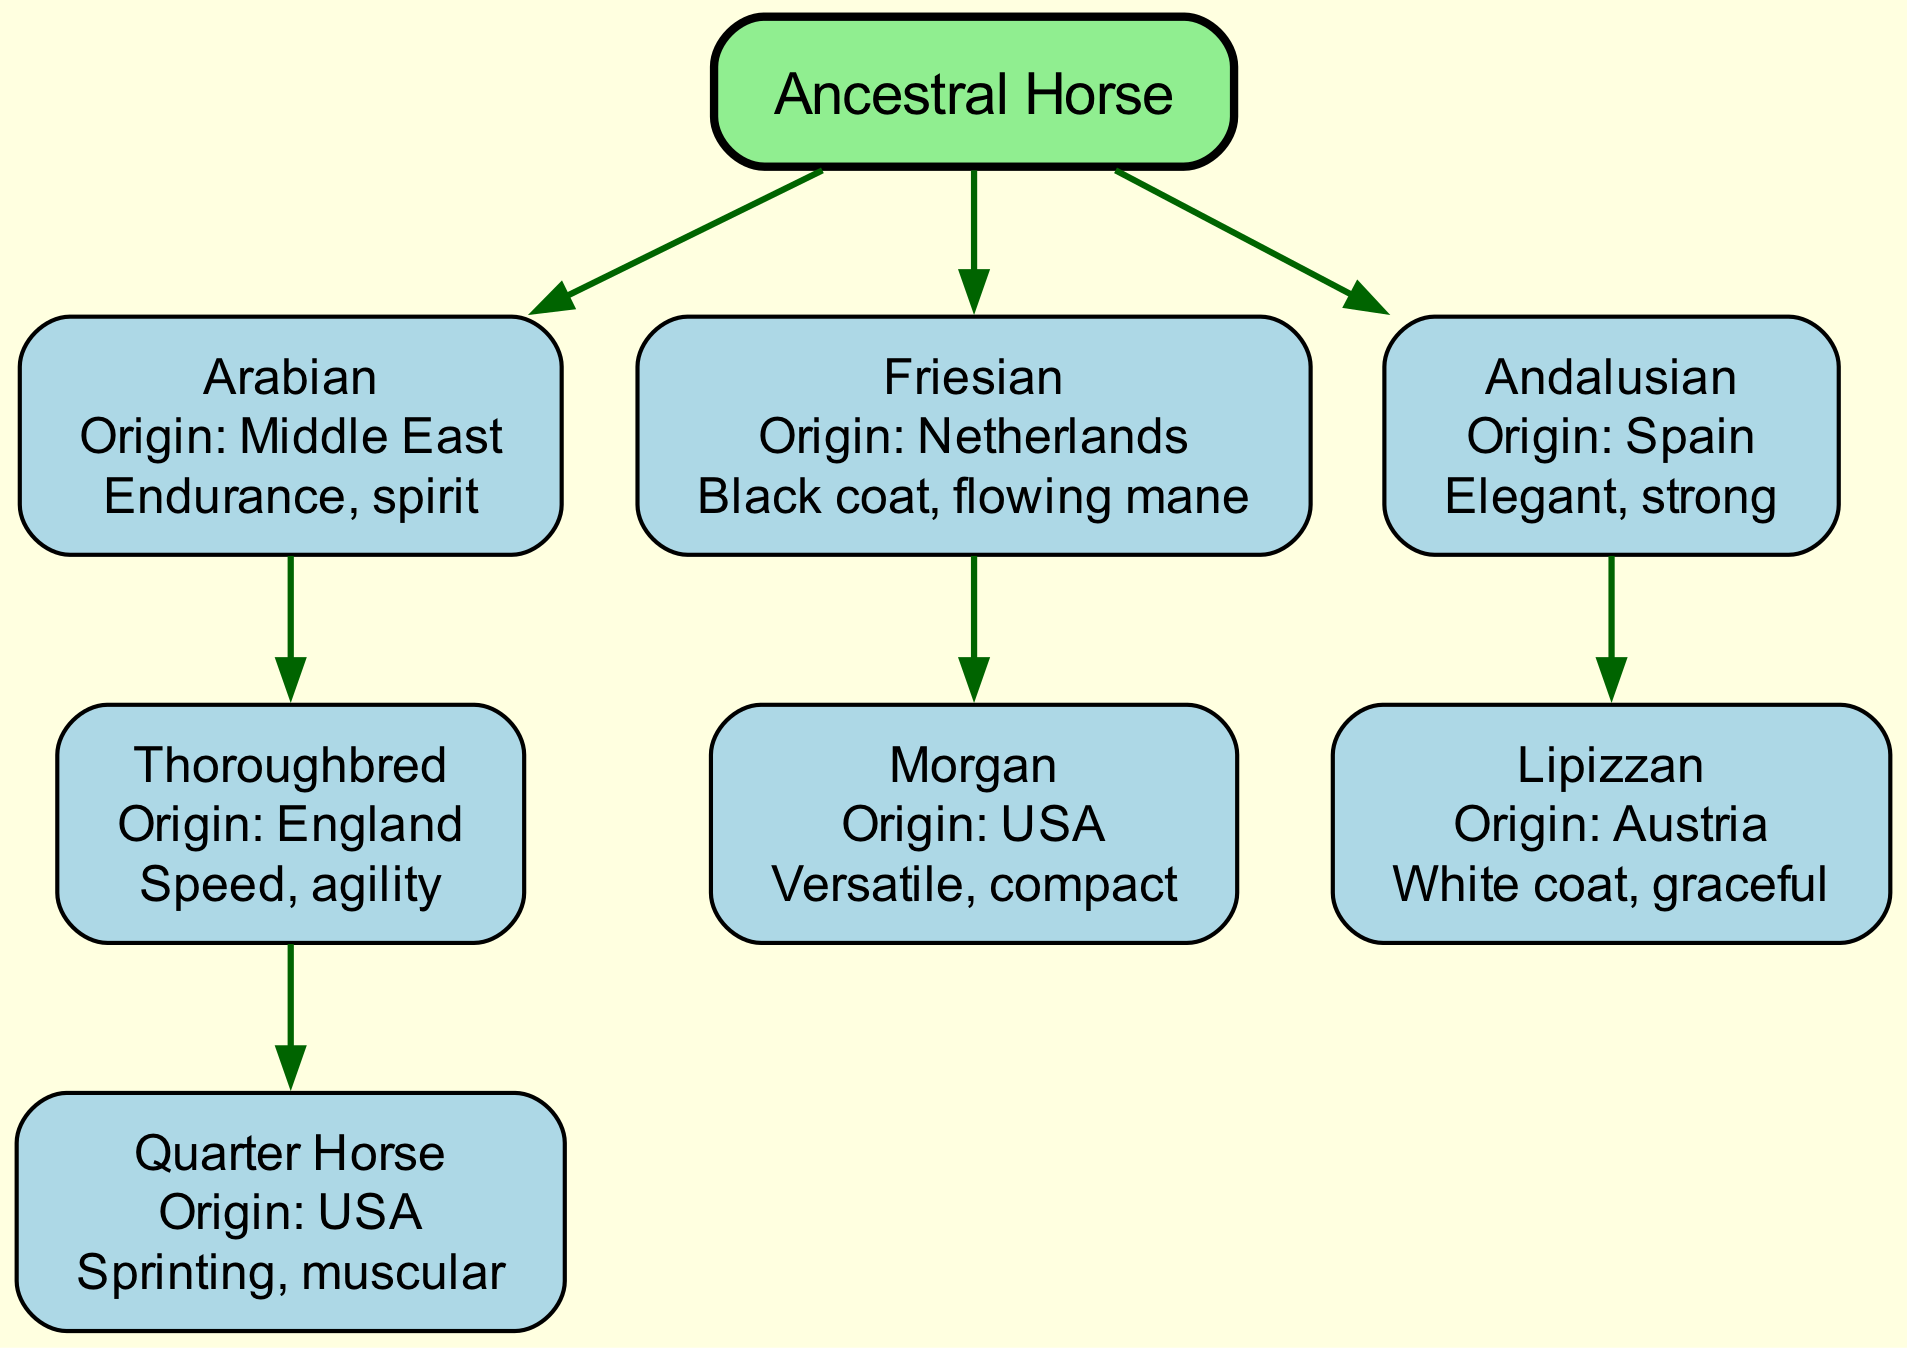What is the origin of the Arabian breed? The diagram indicates that the Arabian breed originated in the Middle East, as labeled next to the Arabian node.
Answer: Middle East Which breed comes from the Netherlands? According to the diagram, the Friesian breed is indicated to come from the Netherlands, as shown in its details.
Answer: Friesian How many descendants does the Thoroughbred have? The Thoroughbred breed has one descendant, the Quarter Horse, which is indicated in the diagram below it.
Answer: 1 What characteristics are attributed to the Andalusian breed? The characteristics listed for the Andalusian breed in the diagram include elegant and strong, as indicated on the node.
Answer: Elegant, strong Which breed is a descendant of the Friesian breed? The diagram shows that the Morgan breed is a descendant of the Friesian, which is directly connected as a child node.
Answer: Morgan What is the main characteristic of the Quarter Horse? The main characteristic listed for the Quarter Horse in the diagram is sprinting and muscular, as noted in its description.
Answer: Sprinting, muscular Which horse breed is known for its white coat? The Lipizzan breed is specifically noted for its white coat in the details presented in the diagram.
Answer: Lipizzan What is the parent breed of the Morgan? According to the diagram, the parent breed of the Morgan is the Friesian, indicated by the direct connection between the two breeds.
Answer: Friesian What is the total number of breeds shown in the family tree? The family tree lists a total of 6 breeds, including the root and all descendants. This can be counted as each node connected in the diagram.
Answer: 6 